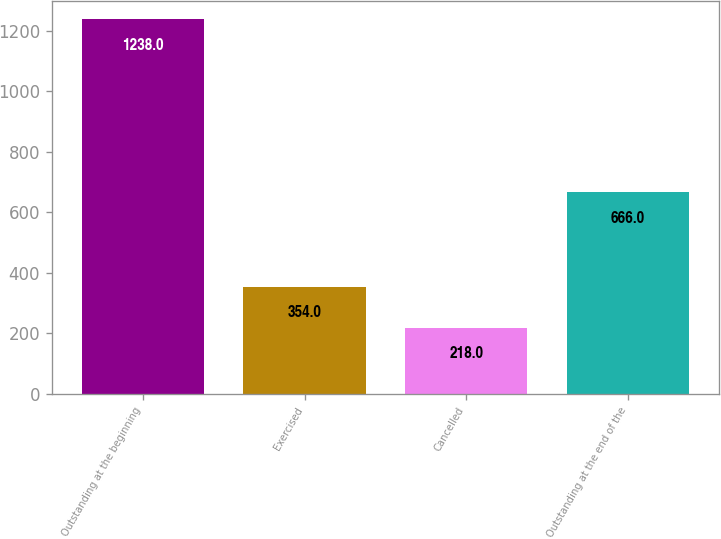<chart> <loc_0><loc_0><loc_500><loc_500><bar_chart><fcel>Outstanding at the beginning<fcel>Exercised<fcel>Cancelled<fcel>Outstanding at the end of the<nl><fcel>1238<fcel>354<fcel>218<fcel>666<nl></chart> 